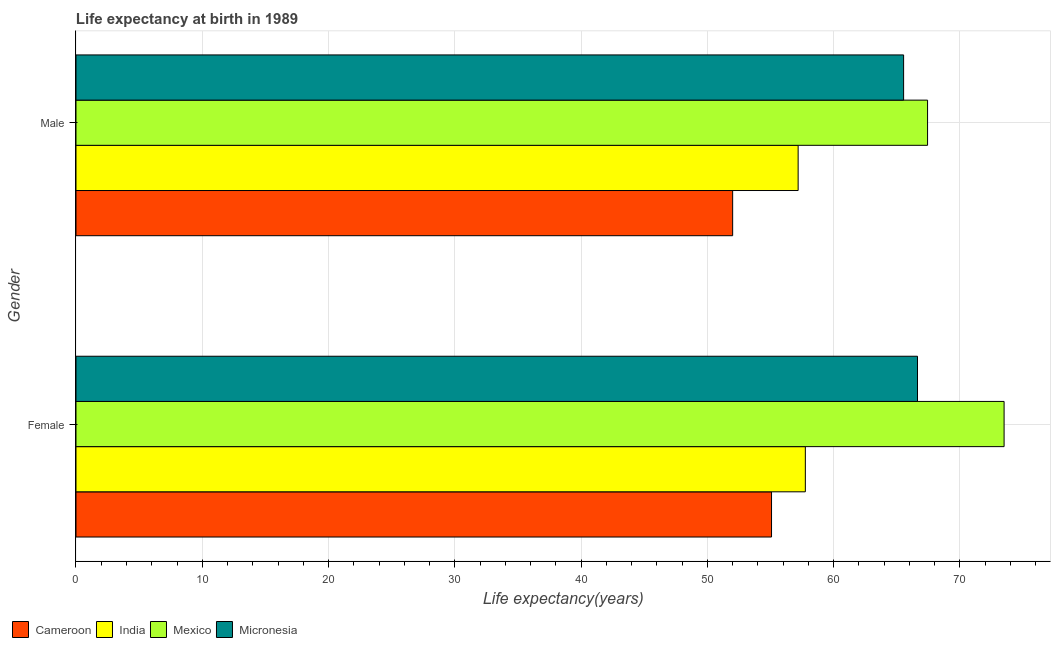Are the number of bars per tick equal to the number of legend labels?
Your response must be concise. Yes. What is the label of the 2nd group of bars from the top?
Your response must be concise. Female. What is the life expectancy(male) in Micronesia?
Ensure brevity in your answer.  65.55. Across all countries, what is the maximum life expectancy(male)?
Your answer should be compact. 67.44. Across all countries, what is the minimum life expectancy(female)?
Provide a short and direct response. 55.09. In which country was the life expectancy(female) maximum?
Offer a very short reply. Mexico. In which country was the life expectancy(female) minimum?
Your answer should be very brief. Cameroon. What is the total life expectancy(male) in the graph?
Offer a very short reply. 242.2. What is the difference between the life expectancy(female) in India and that in Mexico?
Provide a succinct answer. -15.74. What is the difference between the life expectancy(female) in Cameroon and the life expectancy(male) in Mexico?
Keep it short and to the point. -12.36. What is the average life expectancy(male) per country?
Provide a short and direct response. 60.55. What is the difference between the life expectancy(female) and life expectancy(male) in Cameroon?
Your answer should be very brief. 3.08. In how many countries, is the life expectancy(male) greater than 64 years?
Keep it short and to the point. 2. What is the ratio of the life expectancy(female) in Cameroon to that in Micronesia?
Provide a short and direct response. 0.83. Is the life expectancy(male) in Mexico less than that in Cameroon?
Offer a terse response. No. What does the 4th bar from the top in Female represents?
Provide a short and direct response. Cameroon. What does the 1st bar from the bottom in Male represents?
Your answer should be compact. Cameroon. What is the difference between two consecutive major ticks on the X-axis?
Your response must be concise. 10. Are the values on the major ticks of X-axis written in scientific E-notation?
Make the answer very short. No. Does the graph contain any zero values?
Make the answer very short. No. How are the legend labels stacked?
Provide a succinct answer. Horizontal. What is the title of the graph?
Make the answer very short. Life expectancy at birth in 1989. Does "Germany" appear as one of the legend labels in the graph?
Offer a terse response. No. What is the label or title of the X-axis?
Provide a short and direct response. Life expectancy(years). What is the Life expectancy(years) in Cameroon in Female?
Provide a succinct answer. 55.09. What is the Life expectancy(years) in India in Female?
Keep it short and to the point. 57.77. What is the Life expectancy(years) in Mexico in Female?
Keep it short and to the point. 73.51. What is the Life expectancy(years) of Micronesia in Female?
Your answer should be very brief. 66.65. What is the Life expectancy(years) in Cameroon in Male?
Keep it short and to the point. 52.01. What is the Life expectancy(years) of India in Male?
Your answer should be compact. 57.2. What is the Life expectancy(years) in Mexico in Male?
Keep it short and to the point. 67.44. What is the Life expectancy(years) in Micronesia in Male?
Offer a very short reply. 65.55. Across all Gender, what is the maximum Life expectancy(years) of Cameroon?
Offer a terse response. 55.09. Across all Gender, what is the maximum Life expectancy(years) of India?
Make the answer very short. 57.77. Across all Gender, what is the maximum Life expectancy(years) in Mexico?
Your answer should be very brief. 73.51. Across all Gender, what is the maximum Life expectancy(years) of Micronesia?
Make the answer very short. 66.65. Across all Gender, what is the minimum Life expectancy(years) of Cameroon?
Your answer should be very brief. 52.01. Across all Gender, what is the minimum Life expectancy(years) in India?
Ensure brevity in your answer.  57.2. Across all Gender, what is the minimum Life expectancy(years) in Mexico?
Your answer should be compact. 67.44. Across all Gender, what is the minimum Life expectancy(years) of Micronesia?
Provide a succinct answer. 65.55. What is the total Life expectancy(years) of Cameroon in the graph?
Provide a short and direct response. 107.09. What is the total Life expectancy(years) of India in the graph?
Keep it short and to the point. 114.96. What is the total Life expectancy(years) in Mexico in the graph?
Make the answer very short. 140.95. What is the total Life expectancy(years) in Micronesia in the graph?
Your answer should be compact. 132.2. What is the difference between the Life expectancy(years) of Cameroon in Female and that in Male?
Make the answer very short. 3.08. What is the difference between the Life expectancy(years) of India in Female and that in Male?
Make the answer very short. 0.57. What is the difference between the Life expectancy(years) of Mexico in Female and that in Male?
Your response must be concise. 6.06. What is the difference between the Life expectancy(years) of Cameroon in Female and the Life expectancy(years) of India in Male?
Provide a succinct answer. -2.11. What is the difference between the Life expectancy(years) in Cameroon in Female and the Life expectancy(years) in Mexico in Male?
Offer a terse response. -12.36. What is the difference between the Life expectancy(years) of Cameroon in Female and the Life expectancy(years) of Micronesia in Male?
Offer a terse response. -10.46. What is the difference between the Life expectancy(years) in India in Female and the Life expectancy(years) in Mexico in Male?
Make the answer very short. -9.68. What is the difference between the Life expectancy(years) in India in Female and the Life expectancy(years) in Micronesia in Male?
Provide a short and direct response. -7.78. What is the difference between the Life expectancy(years) of Mexico in Female and the Life expectancy(years) of Micronesia in Male?
Make the answer very short. 7.96. What is the average Life expectancy(years) of Cameroon per Gender?
Give a very brief answer. 53.55. What is the average Life expectancy(years) of India per Gender?
Provide a succinct answer. 57.48. What is the average Life expectancy(years) of Mexico per Gender?
Keep it short and to the point. 70.48. What is the average Life expectancy(years) of Micronesia per Gender?
Make the answer very short. 66.1. What is the difference between the Life expectancy(years) in Cameroon and Life expectancy(years) in India in Female?
Ensure brevity in your answer.  -2.68. What is the difference between the Life expectancy(years) in Cameroon and Life expectancy(years) in Mexico in Female?
Offer a very short reply. -18.42. What is the difference between the Life expectancy(years) in Cameroon and Life expectancy(years) in Micronesia in Female?
Make the answer very short. -11.56. What is the difference between the Life expectancy(years) of India and Life expectancy(years) of Mexico in Female?
Ensure brevity in your answer.  -15.74. What is the difference between the Life expectancy(years) in India and Life expectancy(years) in Micronesia in Female?
Your response must be concise. -8.88. What is the difference between the Life expectancy(years) of Mexico and Life expectancy(years) of Micronesia in Female?
Make the answer very short. 6.86. What is the difference between the Life expectancy(years) of Cameroon and Life expectancy(years) of India in Male?
Ensure brevity in your answer.  -5.19. What is the difference between the Life expectancy(years) of Cameroon and Life expectancy(years) of Mexico in Male?
Offer a terse response. -15.44. What is the difference between the Life expectancy(years) in Cameroon and Life expectancy(years) in Micronesia in Male?
Offer a very short reply. -13.54. What is the difference between the Life expectancy(years) of India and Life expectancy(years) of Mexico in Male?
Keep it short and to the point. -10.25. What is the difference between the Life expectancy(years) of India and Life expectancy(years) of Micronesia in Male?
Your answer should be very brief. -8.35. What is the difference between the Life expectancy(years) in Mexico and Life expectancy(years) in Micronesia in Male?
Give a very brief answer. 1.9. What is the ratio of the Life expectancy(years) in Cameroon in Female to that in Male?
Ensure brevity in your answer.  1.06. What is the ratio of the Life expectancy(years) of India in Female to that in Male?
Give a very brief answer. 1.01. What is the ratio of the Life expectancy(years) of Mexico in Female to that in Male?
Offer a terse response. 1.09. What is the ratio of the Life expectancy(years) of Micronesia in Female to that in Male?
Your response must be concise. 1.02. What is the difference between the highest and the second highest Life expectancy(years) of Cameroon?
Provide a succinct answer. 3.08. What is the difference between the highest and the second highest Life expectancy(years) in India?
Give a very brief answer. 0.57. What is the difference between the highest and the second highest Life expectancy(years) of Mexico?
Provide a succinct answer. 6.06. What is the difference between the highest and the second highest Life expectancy(years) of Micronesia?
Give a very brief answer. 1.1. What is the difference between the highest and the lowest Life expectancy(years) in Cameroon?
Make the answer very short. 3.08. What is the difference between the highest and the lowest Life expectancy(years) in India?
Provide a succinct answer. 0.57. What is the difference between the highest and the lowest Life expectancy(years) in Mexico?
Offer a very short reply. 6.06. What is the difference between the highest and the lowest Life expectancy(years) of Micronesia?
Your answer should be compact. 1.1. 